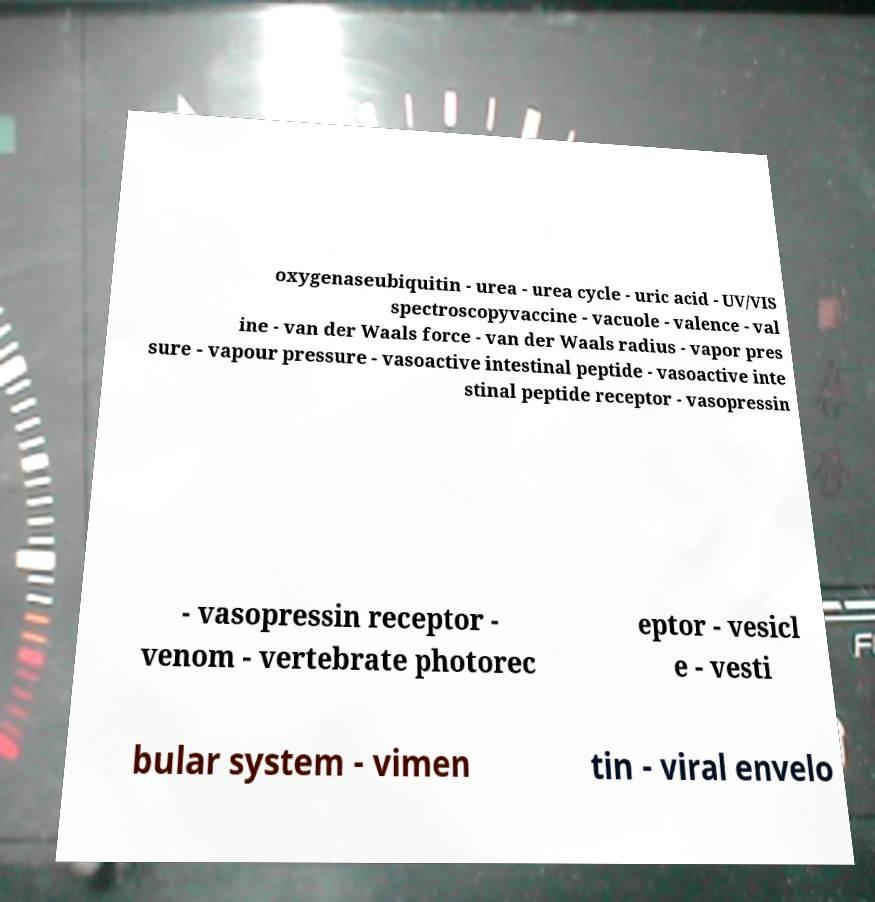What messages or text are displayed in this image? I need them in a readable, typed format. oxygenaseubiquitin - urea - urea cycle - uric acid - UV/VIS spectroscopyvaccine - vacuole - valence - val ine - van der Waals force - van der Waals radius - vapor pres sure - vapour pressure - vasoactive intestinal peptide - vasoactive inte stinal peptide receptor - vasopressin - vasopressin receptor - venom - vertebrate photorec eptor - vesicl e - vesti bular system - vimen tin - viral envelo 